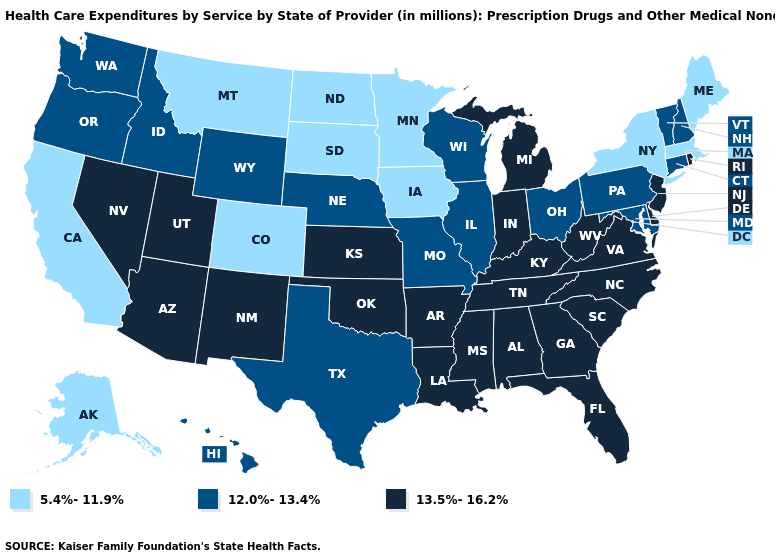Is the legend a continuous bar?
Be succinct. No. What is the lowest value in the South?
Answer briefly. 12.0%-13.4%. What is the value of Delaware?
Quick response, please. 13.5%-16.2%. Name the states that have a value in the range 13.5%-16.2%?
Be succinct. Alabama, Arizona, Arkansas, Delaware, Florida, Georgia, Indiana, Kansas, Kentucky, Louisiana, Michigan, Mississippi, Nevada, New Jersey, New Mexico, North Carolina, Oklahoma, Rhode Island, South Carolina, Tennessee, Utah, Virginia, West Virginia. Does Delaware have a higher value than South Carolina?
Write a very short answer. No. Name the states that have a value in the range 12.0%-13.4%?
Be succinct. Connecticut, Hawaii, Idaho, Illinois, Maryland, Missouri, Nebraska, New Hampshire, Ohio, Oregon, Pennsylvania, Texas, Vermont, Washington, Wisconsin, Wyoming. What is the lowest value in the USA?
Be succinct. 5.4%-11.9%. What is the lowest value in the USA?
Write a very short answer. 5.4%-11.9%. Which states have the lowest value in the Northeast?
Answer briefly. Maine, Massachusetts, New York. What is the value of Illinois?
Concise answer only. 12.0%-13.4%. Does Georgia have the same value as Wyoming?
Short answer required. No. What is the lowest value in the Northeast?
Quick response, please. 5.4%-11.9%. What is the value of Arizona?
Keep it brief. 13.5%-16.2%. Name the states that have a value in the range 13.5%-16.2%?
Write a very short answer. Alabama, Arizona, Arkansas, Delaware, Florida, Georgia, Indiana, Kansas, Kentucky, Louisiana, Michigan, Mississippi, Nevada, New Jersey, New Mexico, North Carolina, Oklahoma, Rhode Island, South Carolina, Tennessee, Utah, Virginia, West Virginia. What is the value of Ohio?
Quick response, please. 12.0%-13.4%. 